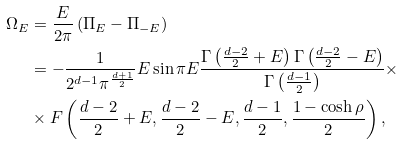Convert formula to latex. <formula><loc_0><loc_0><loc_500><loc_500>\Omega _ { E } & = \frac { E } { 2 \pi } \left ( \Pi _ { E } - \Pi _ { - E } \right ) \, \ \\ & = - \frac { 1 } { 2 ^ { d - 1 } \pi ^ { \frac { d + 1 } { 2 } } } E \sin \pi E \frac { \Gamma \left ( \frac { d - 2 } { 2 } + E \right ) \Gamma \left ( \frac { d - 2 } { 2 } - E \right ) } { \Gamma \left ( \frac { d - 1 } { 2 } \right ) } \times \\ & \times F \left ( \frac { d - 2 } { 2 } + E , \frac { d - 2 } { 2 } - E , \frac { d - 1 } { 2 } , \frac { 1 - \cosh \rho } { 2 } \right ) ,</formula> 